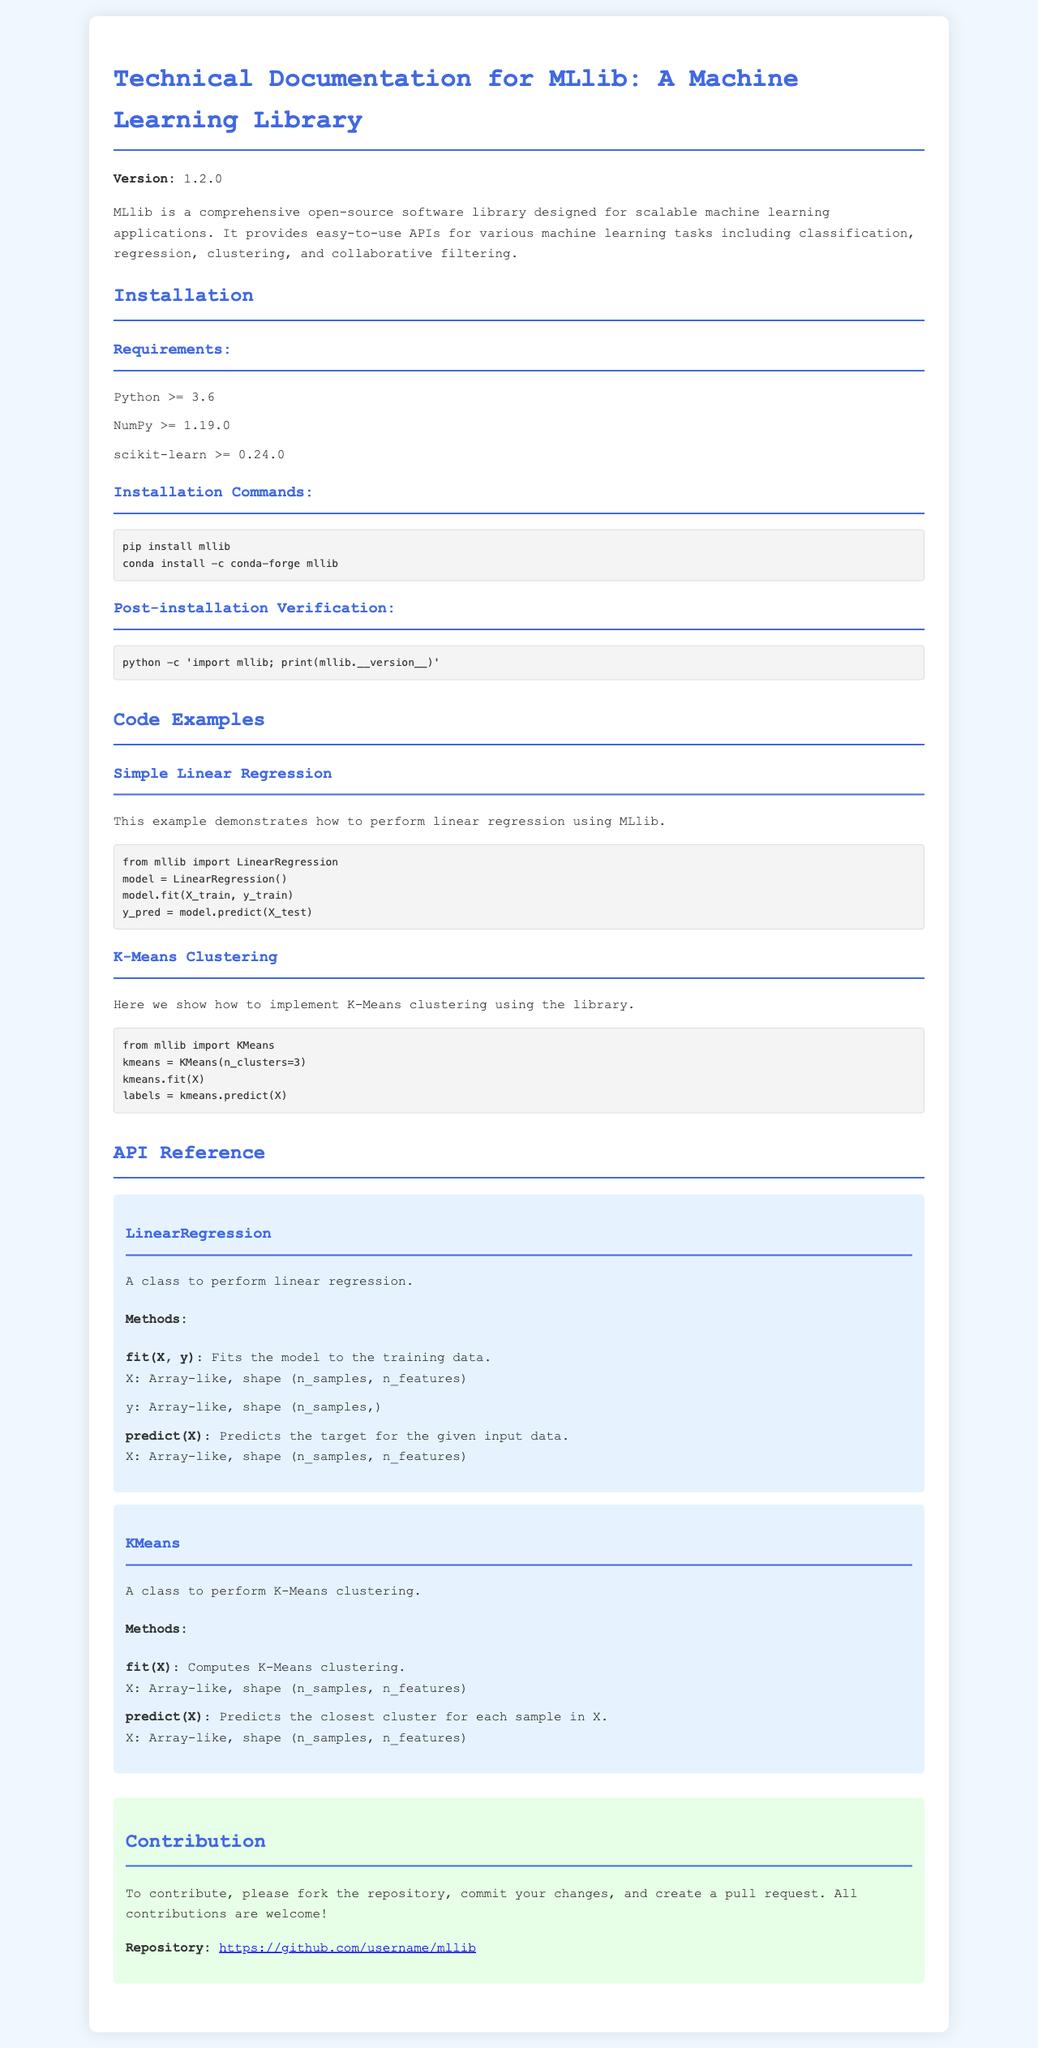What is the version of MLlib? The version is stated prominently at the beginning of the document.
Answer: 1.2.0 What command is used to install MLlib with pip? The installation commands for MLlib include pip commands specifically mentioned in the installation section.
Answer: pip install mllib Which Python version is required for MLlib? The requirements section mentions the minimum version of Python necessary for installation.
Answer: 3.6 What method does the LinearRegression class use to fit the model? The API reference provides specific method names associated with classes, including the method to fit the linear regression model.
Answer: fit How many clusters are set in the KMeans example? The K-Means example specifies the parameter setting for the number of clusters within the code excerpt.
Answer: 3 What is the main purpose of the MLlib library? The introduction paragraph describes the primary function and goal of the MLlib library, summarizing its use case.
Answer: Scalable machine learning applications What should a contributor do to submit changes? The contribution section outlines the necessary steps for contributing to the repository.
Answer: Fork the repository What method predicts the target for the LinearRegression class? The API reference lists the methods available in the LinearRegression class, including those for prediction.
Answer: predict 